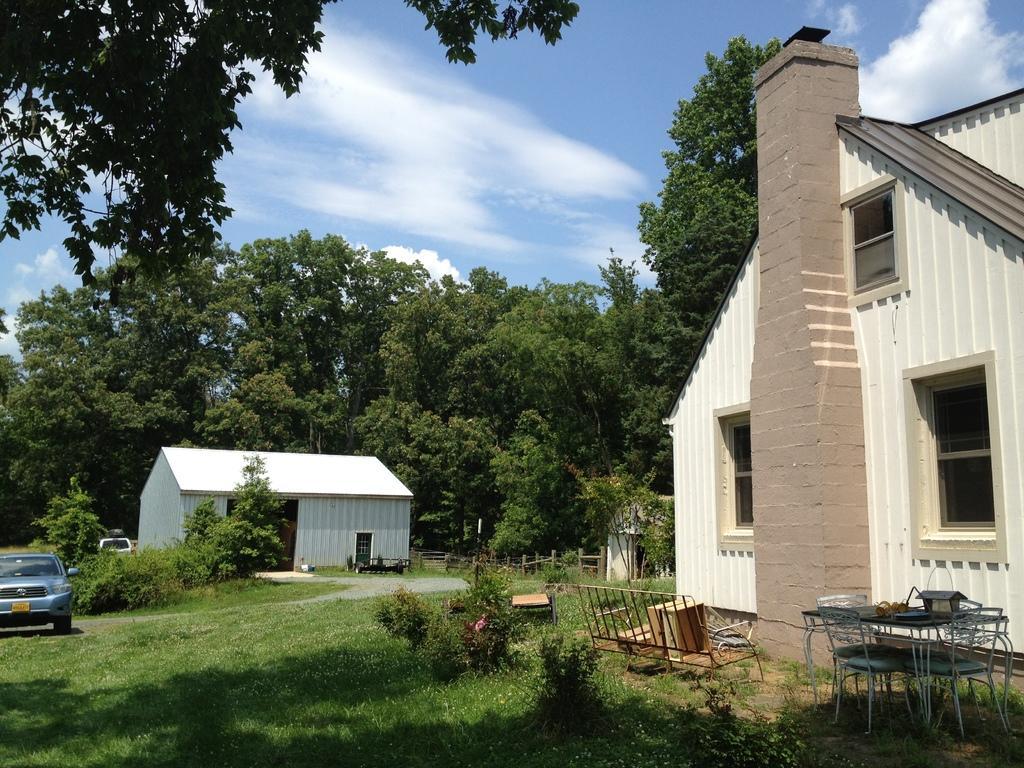Can you describe this image briefly? In this picture we can see grass, few chairs, table, plants and few vehicles, in the background we can find few houses, trees and clouds. 